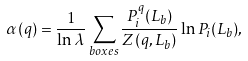<formula> <loc_0><loc_0><loc_500><loc_500>\alpha ( q ) = \frac { 1 } { \ln \lambda } \sum _ { b o x e s } \frac { P _ { i } ^ { q } ( L _ { b } ) } { Z ( q , L _ { b } ) } \ln P _ { i } ( L _ { b } ) ,</formula> 